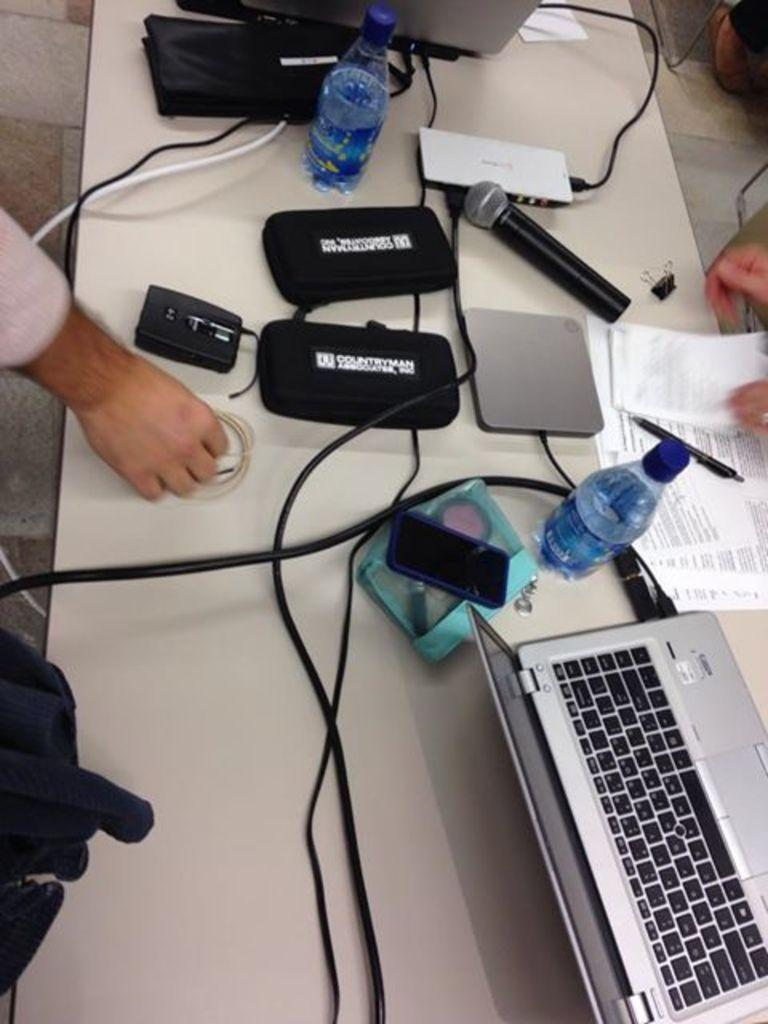What electronic device is on the table in the image? There is a laptop on the table in the image. What other objects can be seen on the table? There is a bottle, a paper, a microphone, and a cable on the table. Are there any people in the image? Yes, there are persons standing near the table. What type of payment is being made in the image? There is no payment being made in the image; it only shows a laptop, other objects on the table, and people standing nearby. 